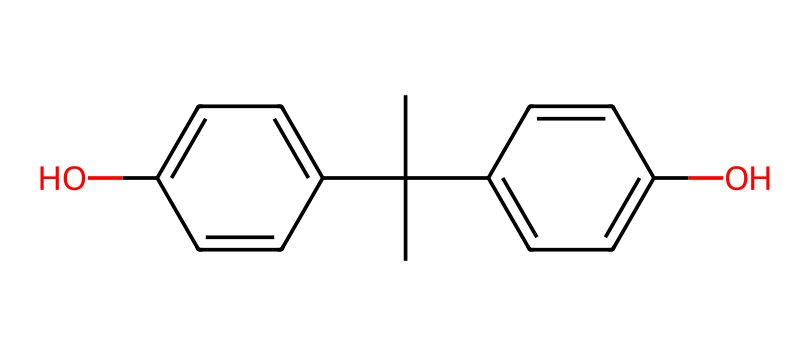What is the name of this compound? The chemical structure corresponds to Bisphenol A, which consists of two phenolic groups connected by a carbon atom.
Answer: Bisphenol A How many hydroxyl groups are present in this chemical? The structure shows two –OH (hydroxyl) groups connected to different aromatic rings, indicating the presence of two hydroxyl groups.
Answer: 2 What is the total number of carbon atoms in Bisphenol A? Upon analyzing the chemical structure, counting yields a total of 15 carbon atoms present in the entire molecule, which include those in both phenolic rings and the connecting structure.
Answer: 15 What type of functional group is present in this molecule? The presence of the –OH groups classifies this compound as a phenol, which is characterized by having hydroxyl groups attached to aromatic rings.
Answer: hydroxyl How many double bonds are present in the aromatic rings of Bisphenol A? By examining the structure, we identify a total of 6 double bonds in the conjugated system within the two benzene rings of Bisphenol A.
Answer: 6 Does Bisphenol A exhibit acidity or basicity? The hydroxyl groups present in the structure impart acidic properties to the chemical by allowing it to donate protons, a characteristic of phenols.
Answer: acidity Is Bisphenol A considered a toxic substance? Research indicates that Bisphenol A has been linked to various health issues, suggesting it may be harmful and is classified as an endocrine disruptor in some studies.
Answer: yes 